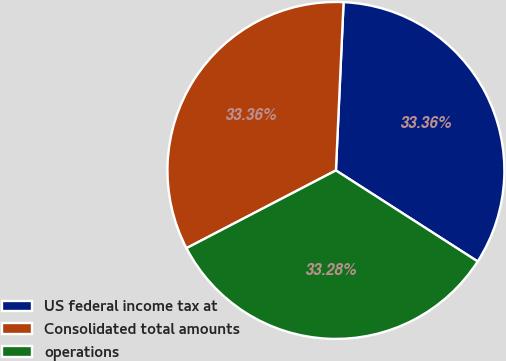Convert chart to OTSL. <chart><loc_0><loc_0><loc_500><loc_500><pie_chart><fcel>US federal income tax at<fcel>Consolidated total amounts<fcel>operations<nl><fcel>33.36%<fcel>33.36%<fcel>33.28%<nl></chart> 